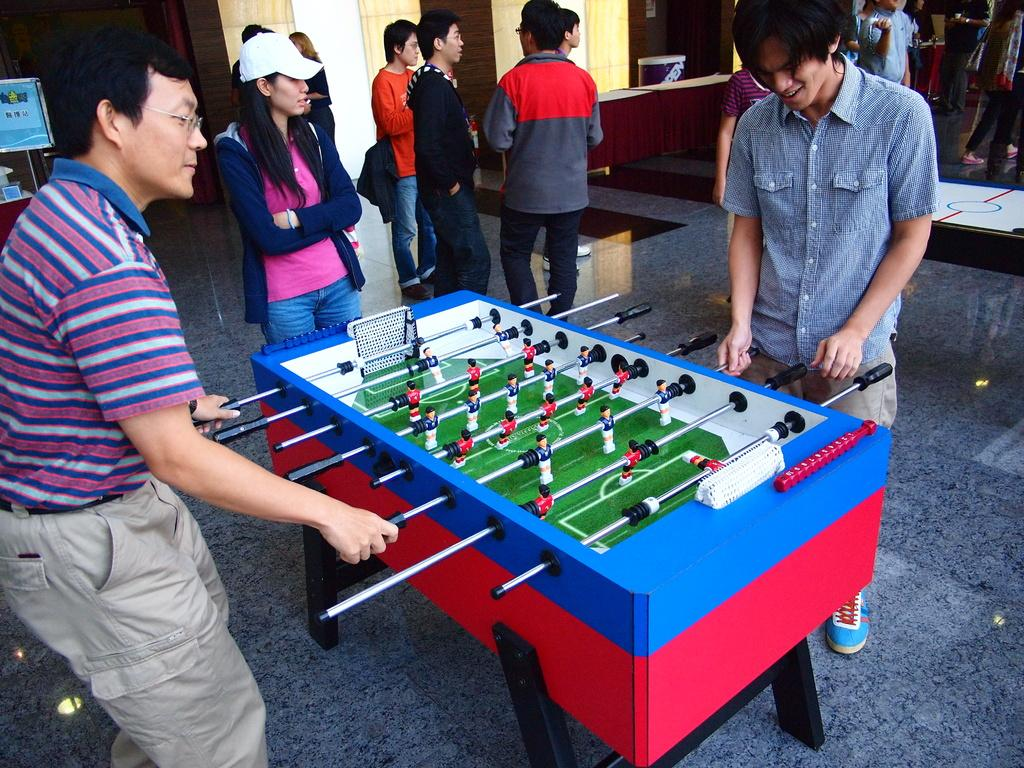What are the two persons in the image doing? The two persons are standing and playing Foosball. What can be seen in the background of the image? There is a group of people standing in the background, as well as a table and a board on a stand. Can you describe the board on a stand in the background? Unfortunately, the facts provided do not give enough information to describe the board on a stand. What is the reason for the jail being present in the image? There is no jail present in the image; it only features two persons playing Foosball and a group of people in the background. 